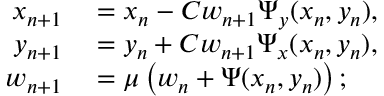Convert formula to latex. <formula><loc_0><loc_0><loc_500><loc_500>\begin{array} { r l } { x _ { n + 1 } } & = x _ { n } - C w _ { n + 1 } \Psi _ { y } ( x _ { n } , y _ { n } ) , } \\ { y _ { n + 1 } } & = y _ { n } + C w _ { n + 1 } \Psi _ { x } ( x _ { n } , y _ { n } ) , } \\ { w _ { n + 1 } } & = \mu \left ( w _ { n } + \Psi ( x _ { n } , y _ { n } ) \right ) ; } \end{array}</formula> 